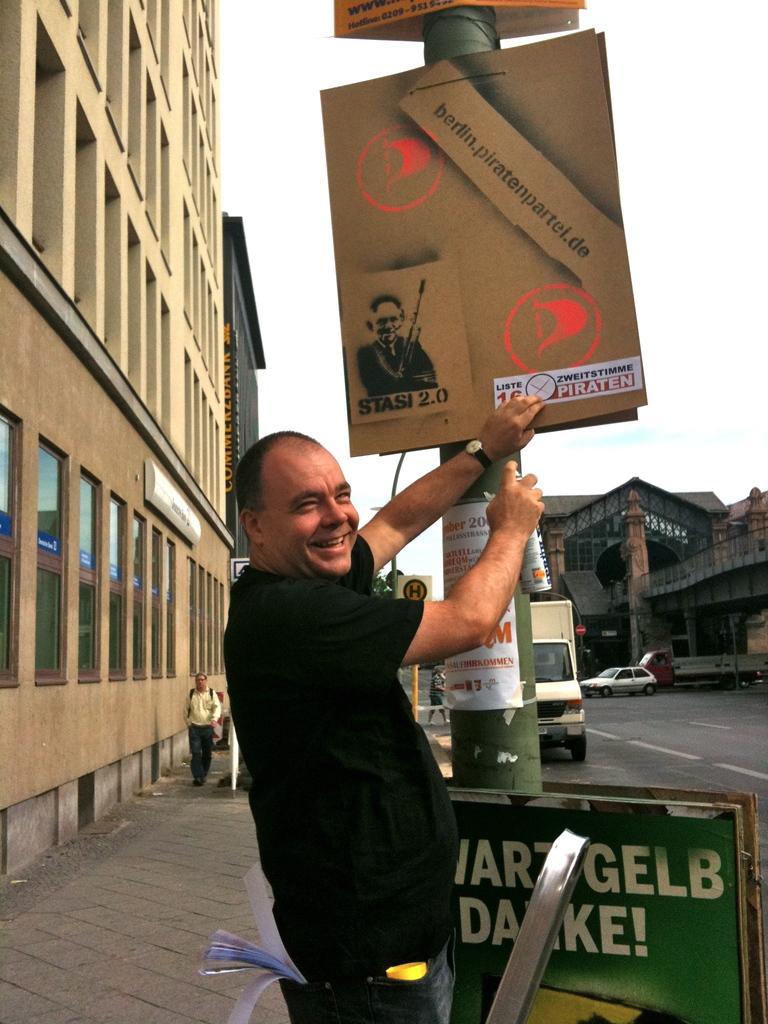In one or two sentences, can you explain what this image depicts? The picture is taken on the streets of a city. In the foreground of the picture there are hoardings, pole and a person holding a spray. On the left there is a building and footpath, there are people walking on the footpath. On the right there are vehicles and buildings. Sky is cloudy. 